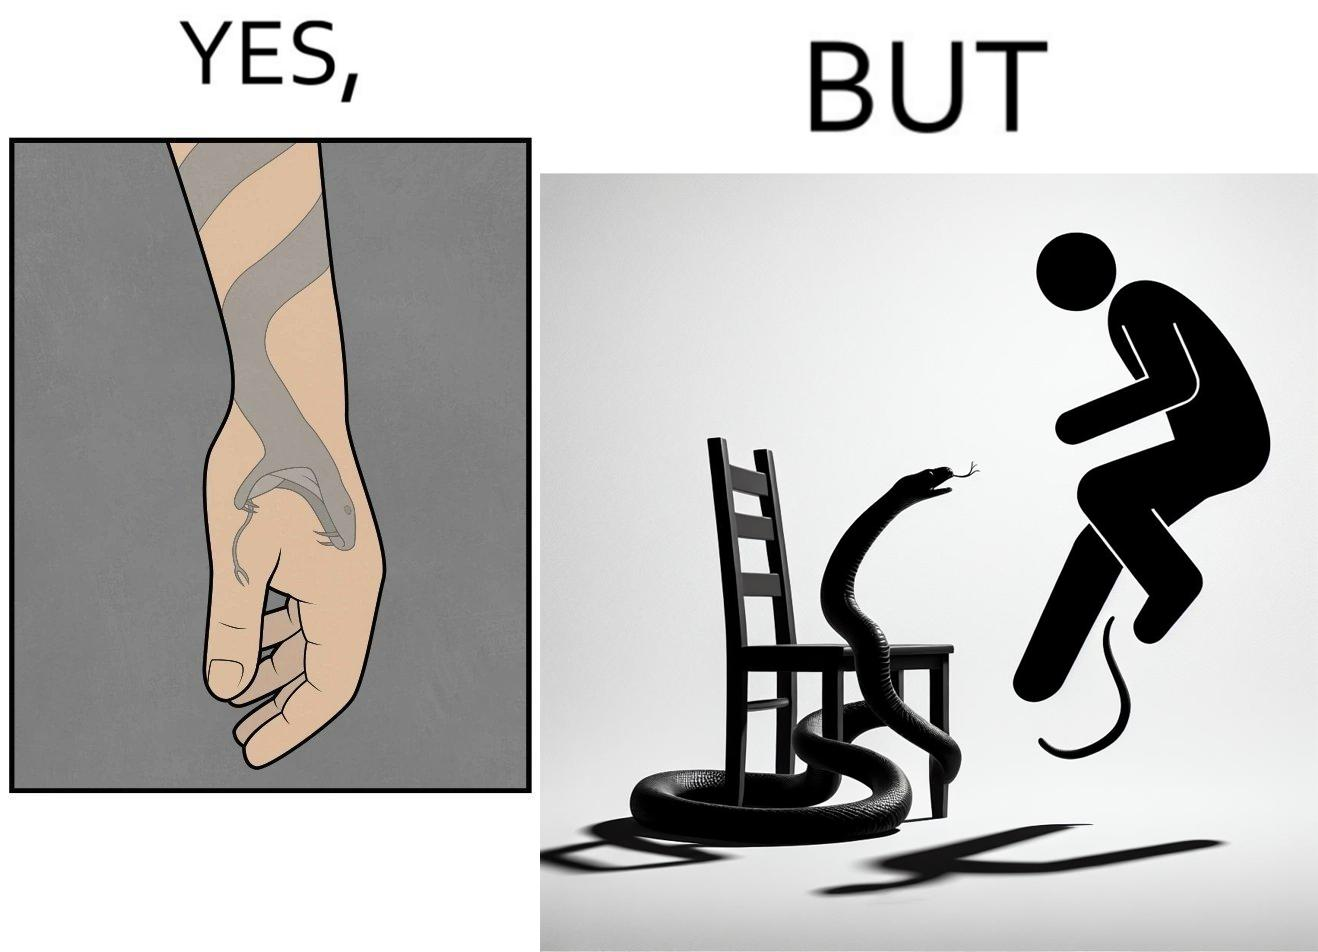Describe what you see in the left and right parts of this image. In the left part of the image: a tattoo of a snake with its mouth wide open on someone's hand In the right part of the image: a person standing on a chair trying save himself from the attack of snake and the snake is probably trying to climb up the chair 